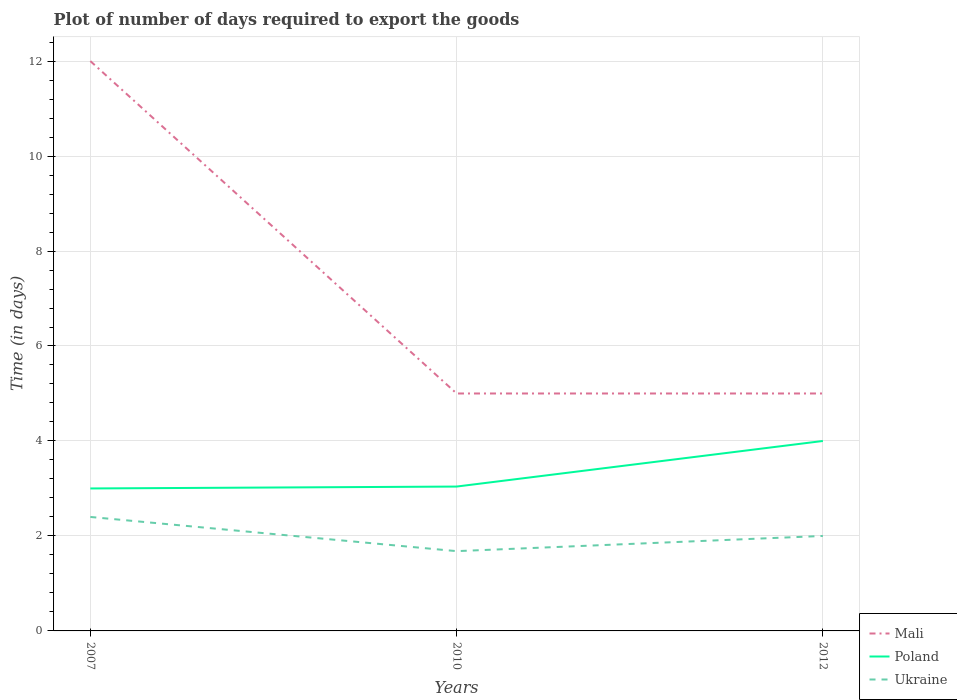How many different coloured lines are there?
Give a very brief answer. 3. Across all years, what is the maximum time required to export goods in Ukraine?
Your answer should be very brief. 1.68. In which year was the time required to export goods in Mali maximum?
Give a very brief answer. 2010. What is the total time required to export goods in Ukraine in the graph?
Give a very brief answer. -0.32. What is the difference between the highest and the second highest time required to export goods in Poland?
Offer a terse response. 1. What is the difference between the highest and the lowest time required to export goods in Mali?
Make the answer very short. 1. How many years are there in the graph?
Your answer should be compact. 3. Does the graph contain grids?
Your response must be concise. Yes. Where does the legend appear in the graph?
Your response must be concise. Bottom right. How many legend labels are there?
Provide a short and direct response. 3. What is the title of the graph?
Provide a short and direct response. Plot of number of days required to export the goods. What is the label or title of the X-axis?
Provide a short and direct response. Years. What is the label or title of the Y-axis?
Your response must be concise. Time (in days). What is the Time (in days) of Mali in 2007?
Your answer should be very brief. 12. What is the Time (in days) in Mali in 2010?
Ensure brevity in your answer.  5. What is the Time (in days) of Poland in 2010?
Provide a succinct answer. 3.04. What is the Time (in days) in Ukraine in 2010?
Ensure brevity in your answer.  1.68. What is the Time (in days) of Poland in 2012?
Keep it short and to the point. 4. Across all years, what is the minimum Time (in days) of Ukraine?
Your response must be concise. 1.68. What is the total Time (in days) of Poland in the graph?
Your response must be concise. 10.04. What is the total Time (in days) of Ukraine in the graph?
Your response must be concise. 6.08. What is the difference between the Time (in days) in Mali in 2007 and that in 2010?
Give a very brief answer. 7. What is the difference between the Time (in days) of Poland in 2007 and that in 2010?
Your answer should be very brief. -0.04. What is the difference between the Time (in days) in Ukraine in 2007 and that in 2010?
Offer a terse response. 0.72. What is the difference between the Time (in days) in Poland in 2007 and that in 2012?
Provide a short and direct response. -1. What is the difference between the Time (in days) in Ukraine in 2007 and that in 2012?
Your answer should be very brief. 0.4. What is the difference between the Time (in days) of Poland in 2010 and that in 2012?
Provide a short and direct response. -0.96. What is the difference between the Time (in days) of Ukraine in 2010 and that in 2012?
Your answer should be very brief. -0.32. What is the difference between the Time (in days) in Mali in 2007 and the Time (in days) in Poland in 2010?
Ensure brevity in your answer.  8.96. What is the difference between the Time (in days) of Mali in 2007 and the Time (in days) of Ukraine in 2010?
Your response must be concise. 10.32. What is the difference between the Time (in days) of Poland in 2007 and the Time (in days) of Ukraine in 2010?
Offer a very short reply. 1.32. What is the difference between the Time (in days) of Mali in 2007 and the Time (in days) of Poland in 2012?
Provide a short and direct response. 8. What is the difference between the Time (in days) in Mali in 2007 and the Time (in days) in Ukraine in 2012?
Ensure brevity in your answer.  10. What is the difference between the Time (in days) of Poland in 2007 and the Time (in days) of Ukraine in 2012?
Offer a very short reply. 1. What is the difference between the Time (in days) of Mali in 2010 and the Time (in days) of Ukraine in 2012?
Offer a very short reply. 3. What is the average Time (in days) of Mali per year?
Your response must be concise. 7.33. What is the average Time (in days) of Poland per year?
Offer a terse response. 3.35. What is the average Time (in days) of Ukraine per year?
Your answer should be compact. 2.03. In the year 2007, what is the difference between the Time (in days) in Mali and Time (in days) in Poland?
Your answer should be compact. 9. In the year 2010, what is the difference between the Time (in days) in Mali and Time (in days) in Poland?
Your answer should be compact. 1.96. In the year 2010, what is the difference between the Time (in days) in Mali and Time (in days) in Ukraine?
Give a very brief answer. 3.32. In the year 2010, what is the difference between the Time (in days) of Poland and Time (in days) of Ukraine?
Give a very brief answer. 1.36. In the year 2012, what is the difference between the Time (in days) in Mali and Time (in days) in Ukraine?
Ensure brevity in your answer.  3. In the year 2012, what is the difference between the Time (in days) of Poland and Time (in days) of Ukraine?
Your answer should be very brief. 2. What is the ratio of the Time (in days) of Mali in 2007 to that in 2010?
Give a very brief answer. 2.4. What is the ratio of the Time (in days) in Poland in 2007 to that in 2010?
Offer a very short reply. 0.99. What is the ratio of the Time (in days) of Ukraine in 2007 to that in 2010?
Give a very brief answer. 1.43. What is the ratio of the Time (in days) of Poland in 2007 to that in 2012?
Your answer should be compact. 0.75. What is the ratio of the Time (in days) of Ukraine in 2007 to that in 2012?
Ensure brevity in your answer.  1.2. What is the ratio of the Time (in days) of Poland in 2010 to that in 2012?
Keep it short and to the point. 0.76. What is the ratio of the Time (in days) of Ukraine in 2010 to that in 2012?
Your answer should be very brief. 0.84. What is the difference between the highest and the second highest Time (in days) in Ukraine?
Offer a terse response. 0.4. What is the difference between the highest and the lowest Time (in days) in Mali?
Your answer should be compact. 7. What is the difference between the highest and the lowest Time (in days) of Ukraine?
Provide a short and direct response. 0.72. 